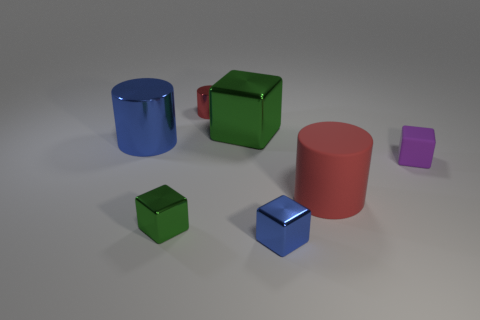Add 2 small purple rubber things. How many objects exist? 9 Subtract all cylinders. How many objects are left? 4 Add 2 large red objects. How many large red objects are left? 3 Add 7 large green shiny objects. How many large green shiny objects exist? 8 Subtract 0 cyan cylinders. How many objects are left? 7 Subtract all red matte things. Subtract all tiny purple objects. How many objects are left? 5 